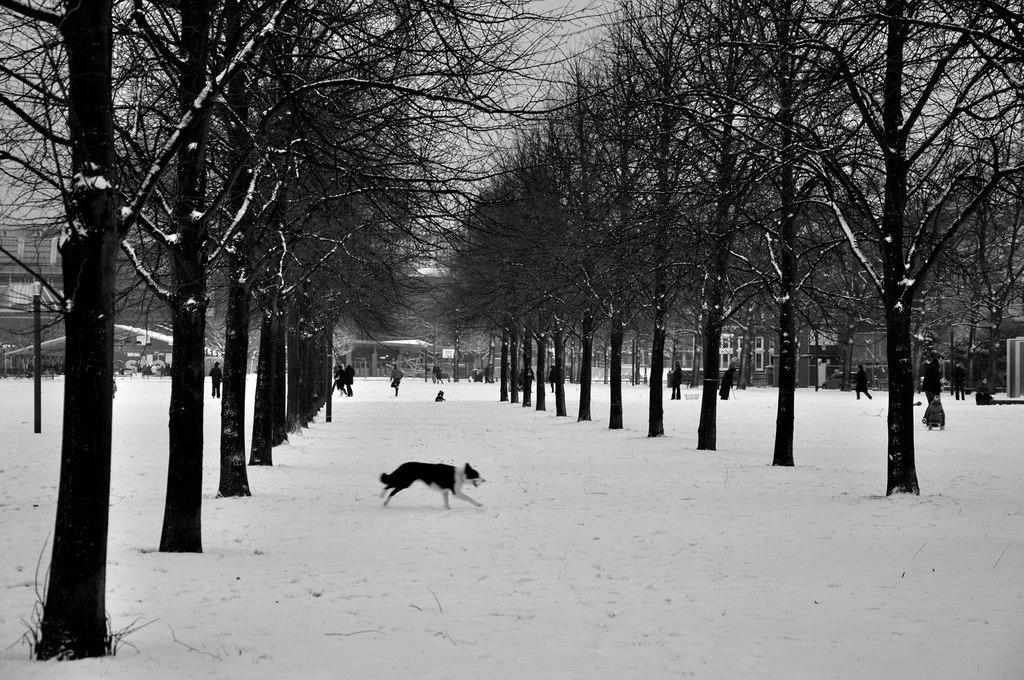What type of vegetation is present in the image? There are trees in the image. What animals can be seen in the image? There are dogs in the image. Are there any human figures in the image? Yes, there are people in the image. What is the weather like in the image? There is snow in the image, indicating a cold or wintery environment. What structures are visible in the image? There are poles and buildings in the image. What can be seen in the background of the image? The sky is visible in the background of the image. What type of leather is being used to make the toy in the image? There is no toy or leather present in the image. What is the point of the image? The image does not have a specific point or purpose; it is simply a representation of the scene described in the facts. 